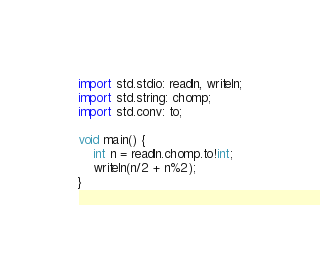Convert code to text. <code><loc_0><loc_0><loc_500><loc_500><_D_>import std.stdio: readln, writeln;
import std.string: chomp;
import std.conv: to;

void main() {
	int n = readln.chomp.to!int;
	writeln(n/2 + n%2);
}
</code> 